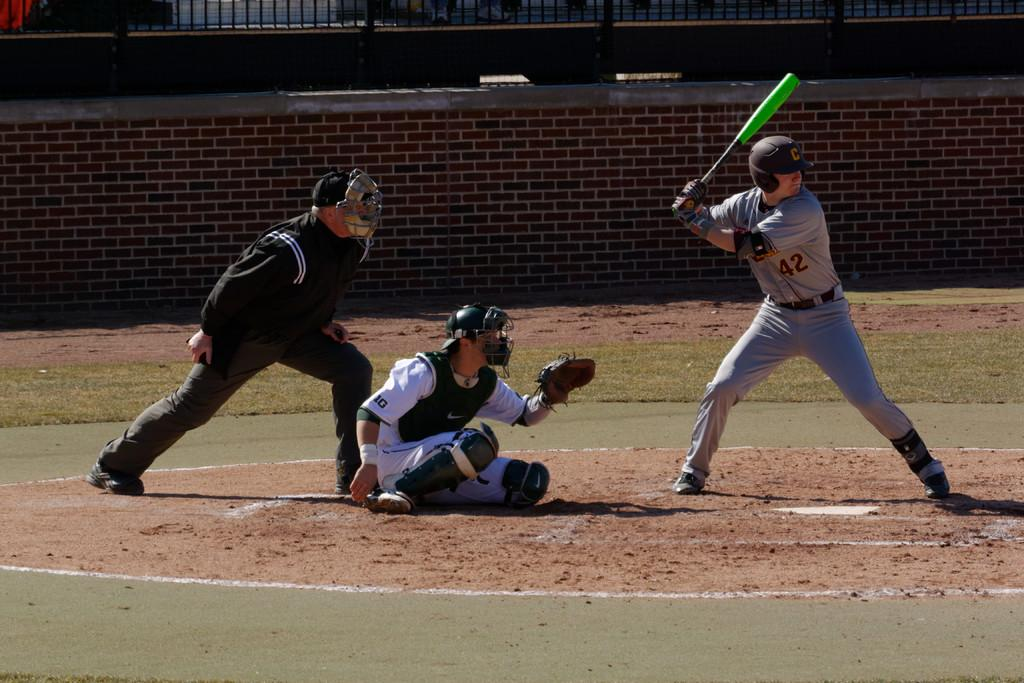<image>
Provide a brief description of the given image. a basball player with a green bat has the number 42 on his shirt 